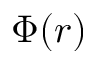<formula> <loc_0><loc_0><loc_500><loc_500>\Phi ( r )</formula> 